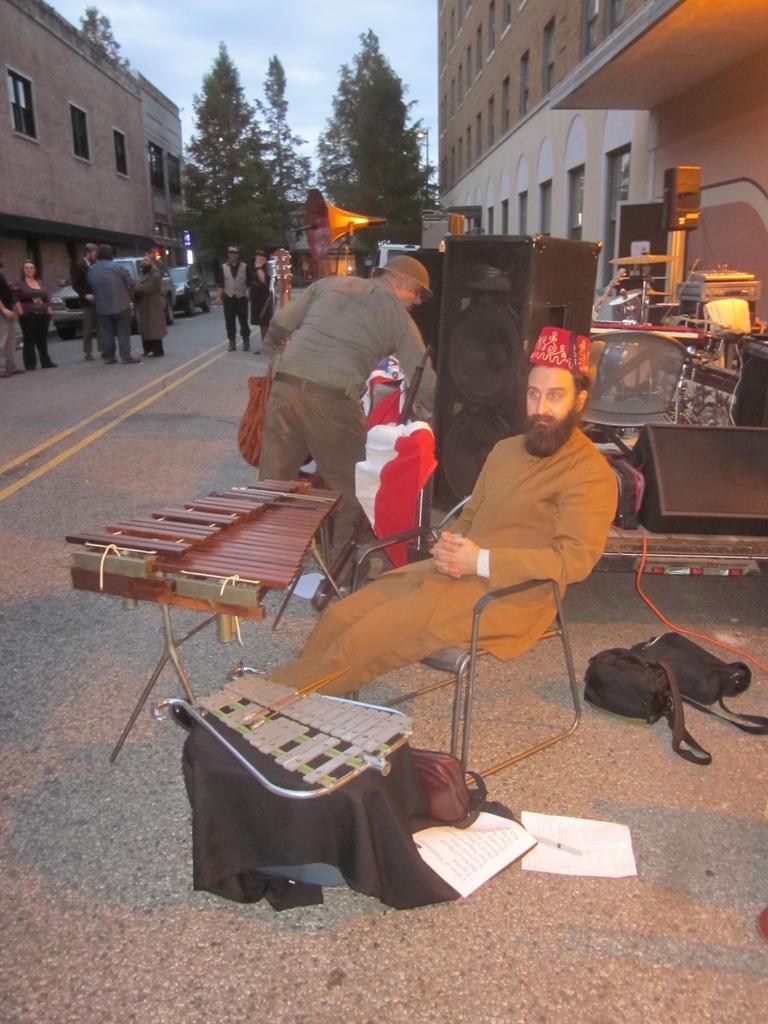In one or two sentences, can you explain what this image depicts? This image consists of many people. The man wearing a brown dress is sitting in a chair. In front of him, there are musical instruments. At the bottom, there is a road. Behind him, there is a speaker. On the left and right, there are building. In the background, we can see trees along with the sky. 